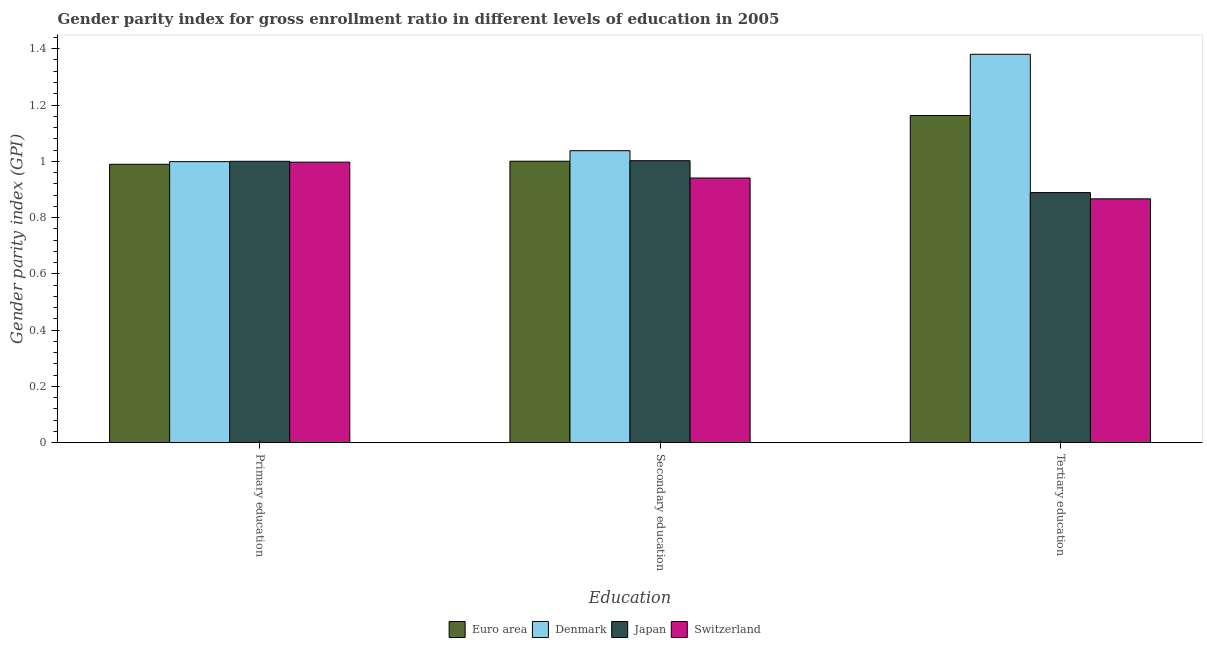How many different coloured bars are there?
Provide a succinct answer. 4. Are the number of bars on each tick of the X-axis equal?
Offer a very short reply. Yes. How many bars are there on the 3rd tick from the right?
Offer a terse response. 4. What is the gender parity index in primary education in Japan?
Keep it short and to the point. 1. Across all countries, what is the maximum gender parity index in tertiary education?
Your answer should be compact. 1.38. Across all countries, what is the minimum gender parity index in secondary education?
Ensure brevity in your answer.  0.94. In which country was the gender parity index in tertiary education minimum?
Make the answer very short. Switzerland. What is the total gender parity index in tertiary education in the graph?
Offer a terse response. 4.3. What is the difference between the gender parity index in tertiary education in Switzerland and that in Euro area?
Provide a short and direct response. -0.3. What is the difference between the gender parity index in secondary education in Switzerland and the gender parity index in tertiary education in Euro area?
Your answer should be compact. -0.22. What is the average gender parity index in secondary education per country?
Offer a terse response. 1. What is the difference between the gender parity index in primary education and gender parity index in tertiary education in Japan?
Keep it short and to the point. 0.11. In how many countries, is the gender parity index in primary education greater than 0.68 ?
Give a very brief answer. 4. What is the ratio of the gender parity index in secondary education in Switzerland to that in Japan?
Your answer should be compact. 0.94. Is the difference between the gender parity index in primary education in Denmark and Japan greater than the difference between the gender parity index in tertiary education in Denmark and Japan?
Offer a very short reply. No. What is the difference between the highest and the second highest gender parity index in primary education?
Offer a very short reply. 0. What is the difference between the highest and the lowest gender parity index in secondary education?
Your answer should be compact. 0.1. In how many countries, is the gender parity index in primary education greater than the average gender parity index in primary education taken over all countries?
Make the answer very short. 3. Is the sum of the gender parity index in primary education in Denmark and Japan greater than the maximum gender parity index in secondary education across all countries?
Your response must be concise. Yes. What does the 2nd bar from the left in Tertiary education represents?
Keep it short and to the point. Denmark. Is it the case that in every country, the sum of the gender parity index in primary education and gender parity index in secondary education is greater than the gender parity index in tertiary education?
Keep it short and to the point. Yes. How many bars are there?
Your response must be concise. 12. What is the difference between two consecutive major ticks on the Y-axis?
Provide a short and direct response. 0.2. Are the values on the major ticks of Y-axis written in scientific E-notation?
Offer a terse response. No. Does the graph contain any zero values?
Your response must be concise. No. Does the graph contain grids?
Provide a succinct answer. No. How many legend labels are there?
Give a very brief answer. 4. How are the legend labels stacked?
Keep it short and to the point. Horizontal. What is the title of the graph?
Keep it short and to the point. Gender parity index for gross enrollment ratio in different levels of education in 2005. What is the label or title of the X-axis?
Provide a succinct answer. Education. What is the label or title of the Y-axis?
Provide a short and direct response. Gender parity index (GPI). What is the Gender parity index (GPI) of Euro area in Primary education?
Make the answer very short. 0.99. What is the Gender parity index (GPI) in Denmark in Primary education?
Your answer should be compact. 1. What is the Gender parity index (GPI) of Japan in Primary education?
Offer a very short reply. 1. What is the Gender parity index (GPI) of Switzerland in Primary education?
Provide a short and direct response. 1. What is the Gender parity index (GPI) of Euro area in Secondary education?
Offer a terse response. 1. What is the Gender parity index (GPI) in Denmark in Secondary education?
Your answer should be very brief. 1.04. What is the Gender parity index (GPI) in Japan in Secondary education?
Keep it short and to the point. 1. What is the Gender parity index (GPI) in Switzerland in Secondary education?
Give a very brief answer. 0.94. What is the Gender parity index (GPI) in Euro area in Tertiary education?
Your answer should be compact. 1.16. What is the Gender parity index (GPI) in Denmark in Tertiary education?
Offer a terse response. 1.38. What is the Gender parity index (GPI) of Japan in Tertiary education?
Your response must be concise. 0.89. What is the Gender parity index (GPI) of Switzerland in Tertiary education?
Your response must be concise. 0.87. Across all Education, what is the maximum Gender parity index (GPI) in Euro area?
Give a very brief answer. 1.16. Across all Education, what is the maximum Gender parity index (GPI) in Denmark?
Keep it short and to the point. 1.38. Across all Education, what is the maximum Gender parity index (GPI) in Japan?
Your response must be concise. 1. Across all Education, what is the maximum Gender parity index (GPI) of Switzerland?
Provide a short and direct response. 1. Across all Education, what is the minimum Gender parity index (GPI) of Euro area?
Offer a terse response. 0.99. Across all Education, what is the minimum Gender parity index (GPI) in Denmark?
Provide a succinct answer. 1. Across all Education, what is the minimum Gender parity index (GPI) in Japan?
Keep it short and to the point. 0.89. Across all Education, what is the minimum Gender parity index (GPI) in Switzerland?
Your response must be concise. 0.87. What is the total Gender parity index (GPI) of Euro area in the graph?
Your answer should be very brief. 3.15. What is the total Gender parity index (GPI) of Denmark in the graph?
Give a very brief answer. 3.42. What is the total Gender parity index (GPI) of Japan in the graph?
Ensure brevity in your answer.  2.89. What is the total Gender parity index (GPI) in Switzerland in the graph?
Your answer should be very brief. 2.8. What is the difference between the Gender parity index (GPI) of Euro area in Primary education and that in Secondary education?
Your answer should be compact. -0.01. What is the difference between the Gender parity index (GPI) in Denmark in Primary education and that in Secondary education?
Offer a terse response. -0.04. What is the difference between the Gender parity index (GPI) of Japan in Primary education and that in Secondary education?
Give a very brief answer. -0. What is the difference between the Gender parity index (GPI) in Switzerland in Primary education and that in Secondary education?
Give a very brief answer. 0.06. What is the difference between the Gender parity index (GPI) of Euro area in Primary education and that in Tertiary education?
Your answer should be compact. -0.17. What is the difference between the Gender parity index (GPI) of Denmark in Primary education and that in Tertiary education?
Your answer should be compact. -0.38. What is the difference between the Gender parity index (GPI) of Japan in Primary education and that in Tertiary education?
Offer a very short reply. 0.11. What is the difference between the Gender parity index (GPI) in Switzerland in Primary education and that in Tertiary education?
Provide a short and direct response. 0.13. What is the difference between the Gender parity index (GPI) of Euro area in Secondary education and that in Tertiary education?
Offer a very short reply. -0.16. What is the difference between the Gender parity index (GPI) in Denmark in Secondary education and that in Tertiary education?
Make the answer very short. -0.34. What is the difference between the Gender parity index (GPI) of Japan in Secondary education and that in Tertiary education?
Provide a succinct answer. 0.11. What is the difference between the Gender parity index (GPI) of Switzerland in Secondary education and that in Tertiary education?
Your answer should be very brief. 0.07. What is the difference between the Gender parity index (GPI) of Euro area in Primary education and the Gender parity index (GPI) of Denmark in Secondary education?
Give a very brief answer. -0.05. What is the difference between the Gender parity index (GPI) in Euro area in Primary education and the Gender parity index (GPI) in Japan in Secondary education?
Provide a short and direct response. -0.01. What is the difference between the Gender parity index (GPI) in Euro area in Primary education and the Gender parity index (GPI) in Switzerland in Secondary education?
Keep it short and to the point. 0.05. What is the difference between the Gender parity index (GPI) of Denmark in Primary education and the Gender parity index (GPI) of Japan in Secondary education?
Your answer should be very brief. -0. What is the difference between the Gender parity index (GPI) of Denmark in Primary education and the Gender parity index (GPI) of Switzerland in Secondary education?
Ensure brevity in your answer.  0.06. What is the difference between the Gender parity index (GPI) in Japan in Primary education and the Gender parity index (GPI) in Switzerland in Secondary education?
Ensure brevity in your answer.  0.06. What is the difference between the Gender parity index (GPI) of Euro area in Primary education and the Gender parity index (GPI) of Denmark in Tertiary education?
Ensure brevity in your answer.  -0.39. What is the difference between the Gender parity index (GPI) of Euro area in Primary education and the Gender parity index (GPI) of Japan in Tertiary education?
Offer a terse response. 0.1. What is the difference between the Gender parity index (GPI) in Euro area in Primary education and the Gender parity index (GPI) in Switzerland in Tertiary education?
Provide a short and direct response. 0.12. What is the difference between the Gender parity index (GPI) in Denmark in Primary education and the Gender parity index (GPI) in Japan in Tertiary education?
Your response must be concise. 0.11. What is the difference between the Gender parity index (GPI) in Denmark in Primary education and the Gender parity index (GPI) in Switzerland in Tertiary education?
Your response must be concise. 0.13. What is the difference between the Gender parity index (GPI) of Japan in Primary education and the Gender parity index (GPI) of Switzerland in Tertiary education?
Give a very brief answer. 0.13. What is the difference between the Gender parity index (GPI) of Euro area in Secondary education and the Gender parity index (GPI) of Denmark in Tertiary education?
Your answer should be compact. -0.38. What is the difference between the Gender parity index (GPI) in Euro area in Secondary education and the Gender parity index (GPI) in Japan in Tertiary education?
Your response must be concise. 0.11. What is the difference between the Gender parity index (GPI) in Euro area in Secondary education and the Gender parity index (GPI) in Switzerland in Tertiary education?
Ensure brevity in your answer.  0.13. What is the difference between the Gender parity index (GPI) of Denmark in Secondary education and the Gender parity index (GPI) of Japan in Tertiary education?
Offer a terse response. 0.15. What is the difference between the Gender parity index (GPI) of Denmark in Secondary education and the Gender parity index (GPI) of Switzerland in Tertiary education?
Give a very brief answer. 0.17. What is the difference between the Gender parity index (GPI) in Japan in Secondary education and the Gender parity index (GPI) in Switzerland in Tertiary education?
Provide a short and direct response. 0.14. What is the average Gender parity index (GPI) of Euro area per Education?
Provide a succinct answer. 1.05. What is the average Gender parity index (GPI) of Denmark per Education?
Offer a very short reply. 1.14. What is the average Gender parity index (GPI) in Japan per Education?
Offer a terse response. 0.96. What is the average Gender parity index (GPI) of Switzerland per Education?
Provide a short and direct response. 0.93. What is the difference between the Gender parity index (GPI) in Euro area and Gender parity index (GPI) in Denmark in Primary education?
Give a very brief answer. -0.01. What is the difference between the Gender parity index (GPI) of Euro area and Gender parity index (GPI) of Japan in Primary education?
Your answer should be compact. -0.01. What is the difference between the Gender parity index (GPI) of Euro area and Gender parity index (GPI) of Switzerland in Primary education?
Offer a terse response. -0.01. What is the difference between the Gender parity index (GPI) in Denmark and Gender parity index (GPI) in Japan in Primary education?
Your answer should be very brief. -0. What is the difference between the Gender parity index (GPI) in Denmark and Gender parity index (GPI) in Switzerland in Primary education?
Ensure brevity in your answer.  0. What is the difference between the Gender parity index (GPI) of Japan and Gender parity index (GPI) of Switzerland in Primary education?
Your answer should be compact. 0. What is the difference between the Gender parity index (GPI) of Euro area and Gender parity index (GPI) of Denmark in Secondary education?
Give a very brief answer. -0.04. What is the difference between the Gender parity index (GPI) of Euro area and Gender parity index (GPI) of Japan in Secondary education?
Make the answer very short. -0. What is the difference between the Gender parity index (GPI) of Euro area and Gender parity index (GPI) of Switzerland in Secondary education?
Keep it short and to the point. 0.06. What is the difference between the Gender parity index (GPI) in Denmark and Gender parity index (GPI) in Japan in Secondary education?
Your answer should be very brief. 0.04. What is the difference between the Gender parity index (GPI) of Denmark and Gender parity index (GPI) of Switzerland in Secondary education?
Keep it short and to the point. 0.1. What is the difference between the Gender parity index (GPI) in Japan and Gender parity index (GPI) in Switzerland in Secondary education?
Offer a terse response. 0.06. What is the difference between the Gender parity index (GPI) in Euro area and Gender parity index (GPI) in Denmark in Tertiary education?
Your answer should be very brief. -0.22. What is the difference between the Gender parity index (GPI) of Euro area and Gender parity index (GPI) of Japan in Tertiary education?
Your answer should be very brief. 0.27. What is the difference between the Gender parity index (GPI) in Euro area and Gender parity index (GPI) in Switzerland in Tertiary education?
Provide a short and direct response. 0.3. What is the difference between the Gender parity index (GPI) of Denmark and Gender parity index (GPI) of Japan in Tertiary education?
Give a very brief answer. 0.49. What is the difference between the Gender parity index (GPI) of Denmark and Gender parity index (GPI) of Switzerland in Tertiary education?
Your response must be concise. 0.51. What is the difference between the Gender parity index (GPI) of Japan and Gender parity index (GPI) of Switzerland in Tertiary education?
Ensure brevity in your answer.  0.02. What is the ratio of the Gender parity index (GPI) of Euro area in Primary education to that in Secondary education?
Offer a terse response. 0.99. What is the ratio of the Gender parity index (GPI) of Denmark in Primary education to that in Secondary education?
Ensure brevity in your answer.  0.96. What is the ratio of the Gender parity index (GPI) in Japan in Primary education to that in Secondary education?
Your response must be concise. 1. What is the ratio of the Gender parity index (GPI) of Switzerland in Primary education to that in Secondary education?
Give a very brief answer. 1.06. What is the ratio of the Gender parity index (GPI) of Euro area in Primary education to that in Tertiary education?
Give a very brief answer. 0.85. What is the ratio of the Gender parity index (GPI) of Denmark in Primary education to that in Tertiary education?
Your response must be concise. 0.72. What is the ratio of the Gender parity index (GPI) in Japan in Primary education to that in Tertiary education?
Ensure brevity in your answer.  1.13. What is the ratio of the Gender parity index (GPI) of Switzerland in Primary education to that in Tertiary education?
Your response must be concise. 1.15. What is the ratio of the Gender parity index (GPI) in Euro area in Secondary education to that in Tertiary education?
Offer a terse response. 0.86. What is the ratio of the Gender parity index (GPI) in Denmark in Secondary education to that in Tertiary education?
Your response must be concise. 0.75. What is the ratio of the Gender parity index (GPI) in Japan in Secondary education to that in Tertiary education?
Your answer should be very brief. 1.13. What is the ratio of the Gender parity index (GPI) in Switzerland in Secondary education to that in Tertiary education?
Your answer should be compact. 1.09. What is the difference between the highest and the second highest Gender parity index (GPI) in Euro area?
Ensure brevity in your answer.  0.16. What is the difference between the highest and the second highest Gender parity index (GPI) of Denmark?
Provide a short and direct response. 0.34. What is the difference between the highest and the second highest Gender parity index (GPI) in Japan?
Provide a succinct answer. 0. What is the difference between the highest and the second highest Gender parity index (GPI) of Switzerland?
Provide a short and direct response. 0.06. What is the difference between the highest and the lowest Gender parity index (GPI) in Euro area?
Your response must be concise. 0.17. What is the difference between the highest and the lowest Gender parity index (GPI) of Denmark?
Provide a short and direct response. 0.38. What is the difference between the highest and the lowest Gender parity index (GPI) in Japan?
Offer a terse response. 0.11. What is the difference between the highest and the lowest Gender parity index (GPI) of Switzerland?
Make the answer very short. 0.13. 